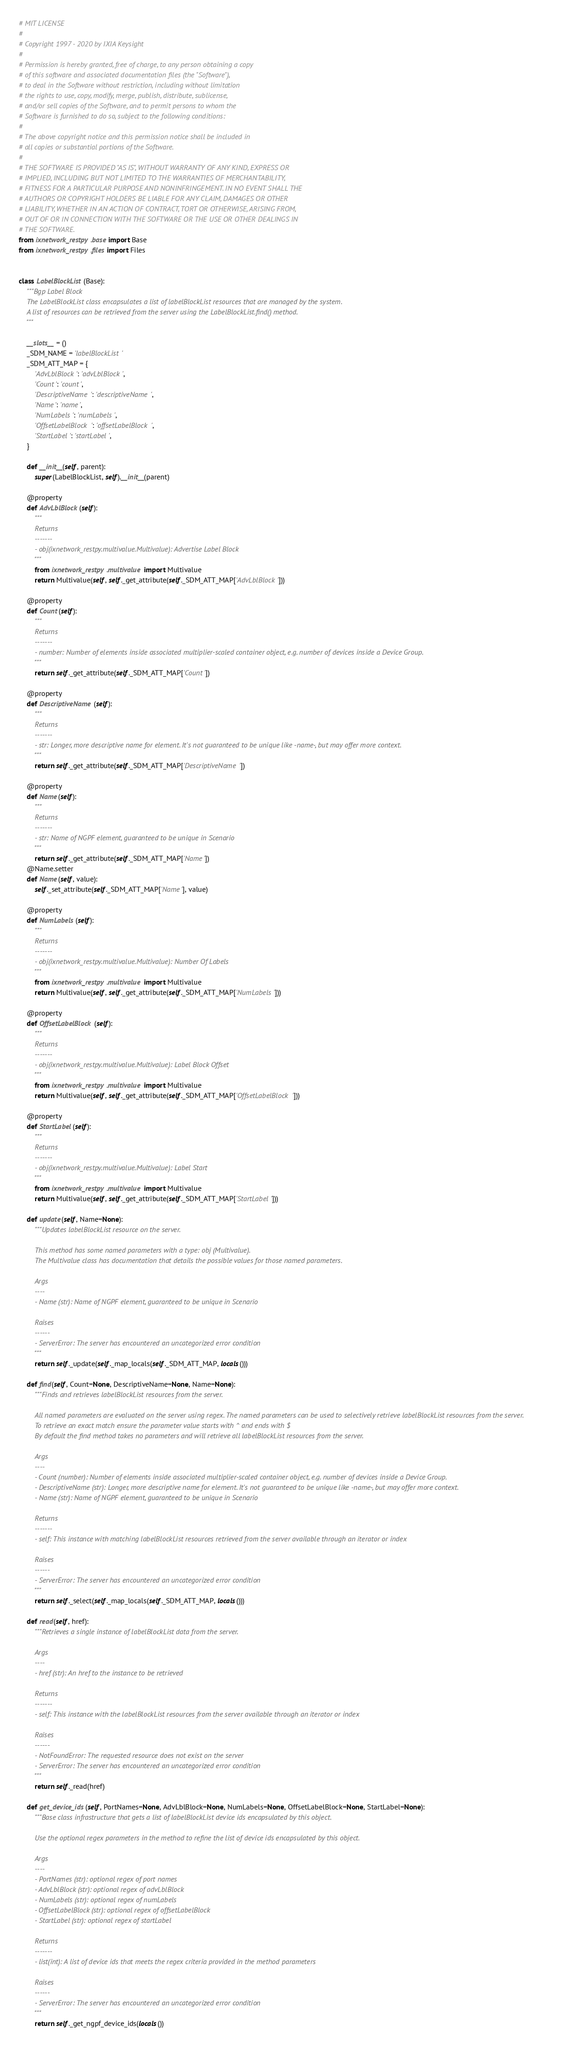Convert code to text. <code><loc_0><loc_0><loc_500><loc_500><_Python_># MIT LICENSE
#
# Copyright 1997 - 2020 by IXIA Keysight
#
# Permission is hereby granted, free of charge, to any person obtaining a copy
# of this software and associated documentation files (the "Software"),
# to deal in the Software without restriction, including without limitation
# the rights to use, copy, modify, merge, publish, distribute, sublicense,
# and/or sell copies of the Software, and to permit persons to whom the
# Software is furnished to do so, subject to the following conditions:
#
# The above copyright notice and this permission notice shall be included in
# all copies or substantial portions of the Software.
#
# THE SOFTWARE IS PROVIDED "AS IS", WITHOUT WARRANTY OF ANY KIND, EXPRESS OR
# IMPLIED, INCLUDING BUT NOT LIMITED TO THE WARRANTIES OF MERCHANTABILITY,
# FITNESS FOR A PARTICULAR PURPOSE AND NONINFRINGEMENT. IN NO EVENT SHALL THE
# AUTHORS OR COPYRIGHT HOLDERS BE LIABLE FOR ANY CLAIM, DAMAGES OR OTHER
# LIABILITY, WHETHER IN AN ACTION OF CONTRACT, TORT OR OTHERWISE, ARISING FROM,
# OUT OF OR IN CONNECTION WITH THE SOFTWARE OR THE USE OR OTHER DEALINGS IN
# THE SOFTWARE. 
from ixnetwork_restpy.base import Base
from ixnetwork_restpy.files import Files


class LabelBlockList(Base):
    """Bgp Label Block
    The LabelBlockList class encapsulates a list of labelBlockList resources that are managed by the system.
    A list of resources can be retrieved from the server using the LabelBlockList.find() method.
    """

    __slots__ = ()
    _SDM_NAME = 'labelBlockList'
    _SDM_ATT_MAP = {
        'AdvLblBlock': 'advLblBlock',
        'Count': 'count',
        'DescriptiveName': 'descriptiveName',
        'Name': 'name',
        'NumLabels': 'numLabels',
        'OffsetLabelBlock': 'offsetLabelBlock',
        'StartLabel': 'startLabel',
    }

    def __init__(self, parent):
        super(LabelBlockList, self).__init__(parent)

    @property
    def AdvLblBlock(self):
        """
        Returns
        -------
        - obj(ixnetwork_restpy.multivalue.Multivalue): Advertise Label Block
        """
        from ixnetwork_restpy.multivalue import Multivalue
        return Multivalue(self, self._get_attribute(self._SDM_ATT_MAP['AdvLblBlock']))

    @property
    def Count(self):
        """
        Returns
        -------
        - number: Number of elements inside associated multiplier-scaled container object, e.g. number of devices inside a Device Group.
        """
        return self._get_attribute(self._SDM_ATT_MAP['Count'])

    @property
    def DescriptiveName(self):
        """
        Returns
        -------
        - str: Longer, more descriptive name for element. It's not guaranteed to be unique like -name-, but may offer more context.
        """
        return self._get_attribute(self._SDM_ATT_MAP['DescriptiveName'])

    @property
    def Name(self):
        """
        Returns
        -------
        - str: Name of NGPF element, guaranteed to be unique in Scenario
        """
        return self._get_attribute(self._SDM_ATT_MAP['Name'])
    @Name.setter
    def Name(self, value):
        self._set_attribute(self._SDM_ATT_MAP['Name'], value)

    @property
    def NumLabels(self):
        """
        Returns
        -------
        - obj(ixnetwork_restpy.multivalue.Multivalue): Number Of Labels
        """
        from ixnetwork_restpy.multivalue import Multivalue
        return Multivalue(self, self._get_attribute(self._SDM_ATT_MAP['NumLabels']))

    @property
    def OffsetLabelBlock(self):
        """
        Returns
        -------
        - obj(ixnetwork_restpy.multivalue.Multivalue): Label Block Offset
        """
        from ixnetwork_restpy.multivalue import Multivalue
        return Multivalue(self, self._get_attribute(self._SDM_ATT_MAP['OffsetLabelBlock']))

    @property
    def StartLabel(self):
        """
        Returns
        -------
        - obj(ixnetwork_restpy.multivalue.Multivalue): Label Start
        """
        from ixnetwork_restpy.multivalue import Multivalue
        return Multivalue(self, self._get_attribute(self._SDM_ATT_MAP['StartLabel']))

    def update(self, Name=None):
        """Updates labelBlockList resource on the server.

        This method has some named parameters with a type: obj (Multivalue).
        The Multivalue class has documentation that details the possible values for those named parameters.

        Args
        ----
        - Name (str): Name of NGPF element, guaranteed to be unique in Scenario

        Raises
        ------
        - ServerError: The server has encountered an uncategorized error condition
        """
        return self._update(self._map_locals(self._SDM_ATT_MAP, locals()))

    def find(self, Count=None, DescriptiveName=None, Name=None):
        """Finds and retrieves labelBlockList resources from the server.

        All named parameters are evaluated on the server using regex. The named parameters can be used to selectively retrieve labelBlockList resources from the server.
        To retrieve an exact match ensure the parameter value starts with ^ and ends with $
        By default the find method takes no parameters and will retrieve all labelBlockList resources from the server.

        Args
        ----
        - Count (number): Number of elements inside associated multiplier-scaled container object, e.g. number of devices inside a Device Group.
        - DescriptiveName (str): Longer, more descriptive name for element. It's not guaranteed to be unique like -name-, but may offer more context.
        - Name (str): Name of NGPF element, guaranteed to be unique in Scenario

        Returns
        -------
        - self: This instance with matching labelBlockList resources retrieved from the server available through an iterator or index

        Raises
        ------
        - ServerError: The server has encountered an uncategorized error condition
        """
        return self._select(self._map_locals(self._SDM_ATT_MAP, locals()))

    def read(self, href):
        """Retrieves a single instance of labelBlockList data from the server.

        Args
        ----
        - href (str): An href to the instance to be retrieved

        Returns
        -------
        - self: This instance with the labelBlockList resources from the server available through an iterator or index

        Raises
        ------
        - NotFoundError: The requested resource does not exist on the server
        - ServerError: The server has encountered an uncategorized error condition
        """
        return self._read(href)

    def get_device_ids(self, PortNames=None, AdvLblBlock=None, NumLabels=None, OffsetLabelBlock=None, StartLabel=None):
        """Base class infrastructure that gets a list of labelBlockList device ids encapsulated by this object.

        Use the optional regex parameters in the method to refine the list of device ids encapsulated by this object.

        Args
        ----
        - PortNames (str): optional regex of port names
        - AdvLblBlock (str): optional regex of advLblBlock
        - NumLabels (str): optional regex of numLabels
        - OffsetLabelBlock (str): optional regex of offsetLabelBlock
        - StartLabel (str): optional regex of startLabel

        Returns
        -------
        - list(int): A list of device ids that meets the regex criteria provided in the method parameters

        Raises
        ------
        - ServerError: The server has encountered an uncategorized error condition
        """
        return self._get_ngpf_device_ids(locals())
</code> 